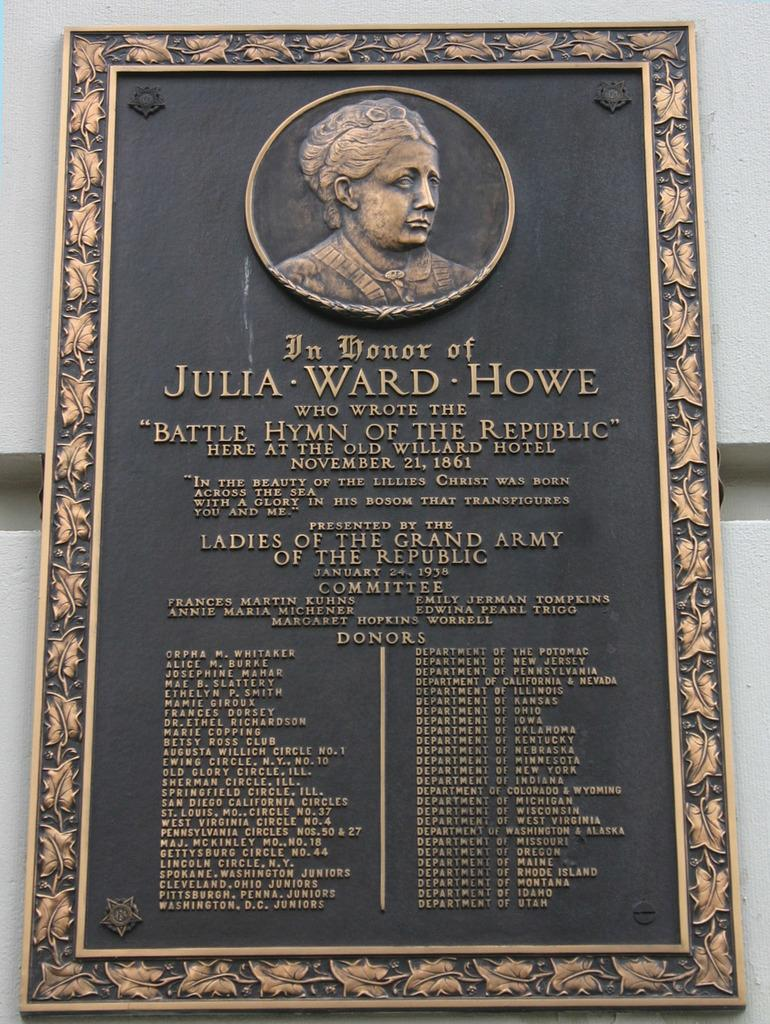<image>
Give a short and clear explanation of the subsequent image. An plaque in honor of Julia Ward Howe lists donors on the bottom. 